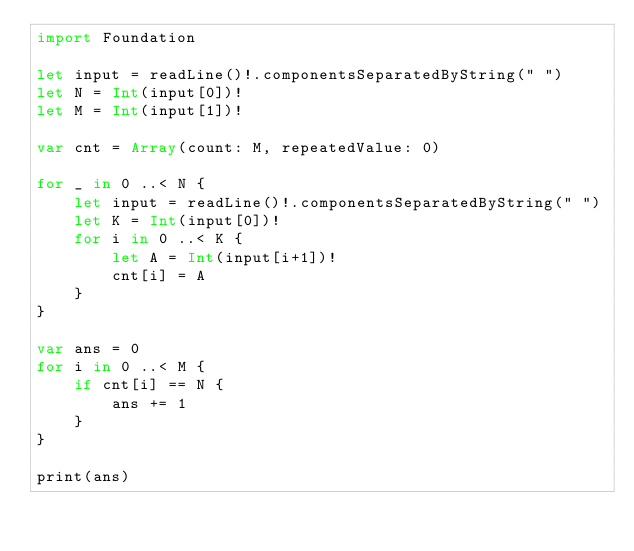<code> <loc_0><loc_0><loc_500><loc_500><_Swift_>import Foundation

let input = readLine()!.componentsSeparatedByString(" ")
let N = Int(input[0])!
let M = Int(input[1])!

var cnt = Array(count: M, repeatedValue: 0)

for _ in 0 ..< N {
    let input = readLine()!.componentsSeparatedByString(" ")
    let K = Int(input[0])!
    for i in 0 ..< K {
        let A = Int(input[i+1])!
        cnt[i] = A
    }
}

var ans = 0
for i in 0 ..< M {
    if cnt[i] == N {
        ans += 1
    }
}

print(ans)
</code> 